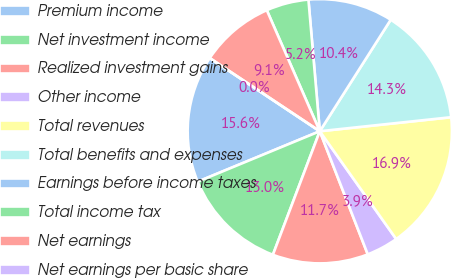Convert chart. <chart><loc_0><loc_0><loc_500><loc_500><pie_chart><fcel>Premium income<fcel>Net investment income<fcel>Realized investment gains<fcel>Other income<fcel>Total revenues<fcel>Total benefits and expenses<fcel>Earnings before income taxes<fcel>Total income tax<fcel>Net earnings<fcel>Net earnings per basic share<nl><fcel>15.58%<fcel>12.99%<fcel>11.69%<fcel>3.9%<fcel>16.88%<fcel>14.29%<fcel>10.39%<fcel>5.2%<fcel>9.09%<fcel>0.0%<nl></chart> 